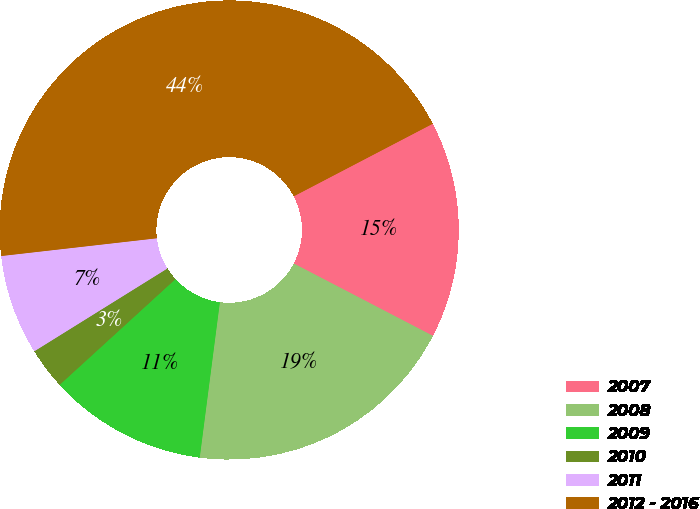Convert chart. <chart><loc_0><loc_0><loc_500><loc_500><pie_chart><fcel>2007<fcel>2008<fcel>2009<fcel>2010<fcel>2011<fcel>2012 - 2016<nl><fcel>15.29%<fcel>19.42%<fcel>11.17%<fcel>2.92%<fcel>7.05%<fcel>44.15%<nl></chart> 